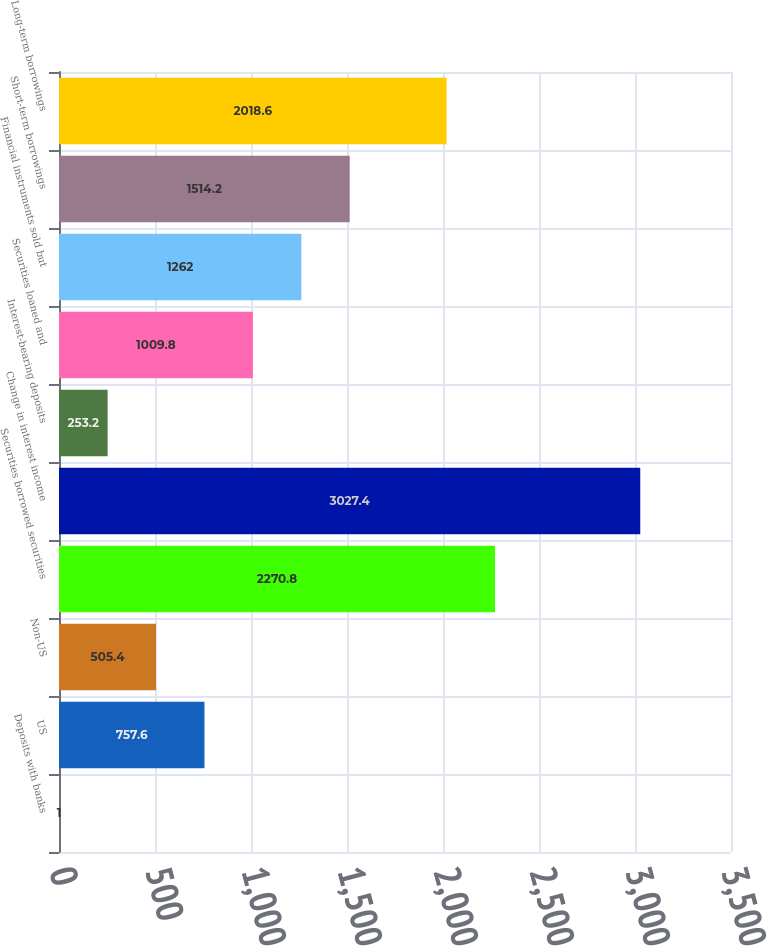<chart> <loc_0><loc_0><loc_500><loc_500><bar_chart><fcel>Deposits with banks<fcel>US<fcel>Non-US<fcel>Securities borrowed securities<fcel>Change in interest income<fcel>Interest-bearing deposits<fcel>Securities loaned and<fcel>Financial instruments sold but<fcel>Short-term borrowings<fcel>Long-term borrowings<nl><fcel>1<fcel>757.6<fcel>505.4<fcel>2270.8<fcel>3027.4<fcel>253.2<fcel>1009.8<fcel>1262<fcel>1514.2<fcel>2018.6<nl></chart> 